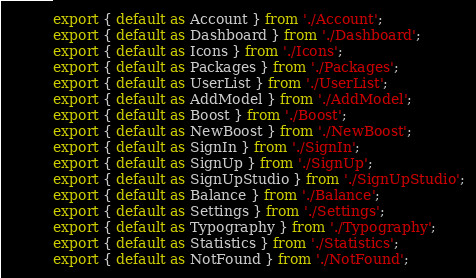<code> <loc_0><loc_0><loc_500><loc_500><_JavaScript_>export { default as Account } from './Account';
export { default as Dashboard } from './Dashboard';
export { default as Icons } from './Icons';
export { default as Packages } from './Packages';
export { default as UserList } from './UserList';
export { default as AddModel } from './AddModel';
export { default as Boost } from './Boost';
export { default as NewBoost } from './NewBoost';
export { default as SignIn } from './SignIn';
export { default as SignUp } from './SignUp';
export { default as SignUpStudio } from './SignUpStudio';
export { default as Balance } from './Balance';
export { default as Settings } from './Settings';
export { default as Typography } from './Typography';
export { default as Statistics } from './Statistics';
export { default as NotFound } from './NotFound';

</code> 